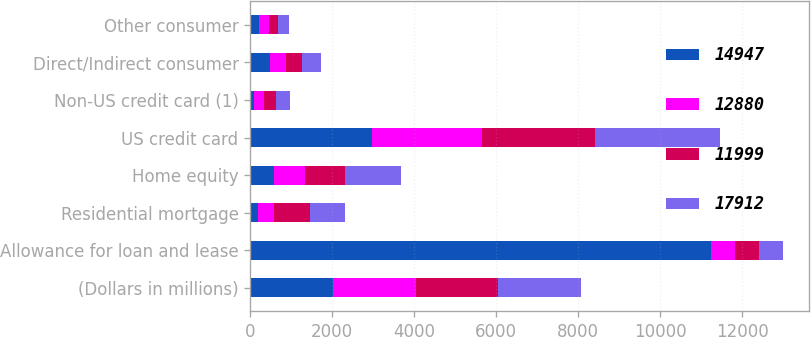<chart> <loc_0><loc_0><loc_500><loc_500><stacked_bar_chart><ecel><fcel>(Dollars in millions)<fcel>Allowance for loan and lease<fcel>Residential mortgage<fcel>Home equity<fcel>US credit card<fcel>Non-US credit card (1)<fcel>Direct/Indirect consumer<fcel>Other consumer<nl><fcel>14947<fcel>2017<fcel>11237<fcel>188<fcel>582<fcel>2968<fcel>103<fcel>487<fcel>216<nl><fcel>12880<fcel>2016<fcel>582<fcel>403<fcel>752<fcel>2691<fcel>238<fcel>392<fcel>232<nl><fcel>11999<fcel>2015<fcel>582<fcel>866<fcel>975<fcel>2738<fcel>275<fcel>383<fcel>224<nl><fcel>17912<fcel>2014<fcel>582<fcel>855<fcel>1364<fcel>3068<fcel>357<fcel>456<fcel>268<nl></chart> 